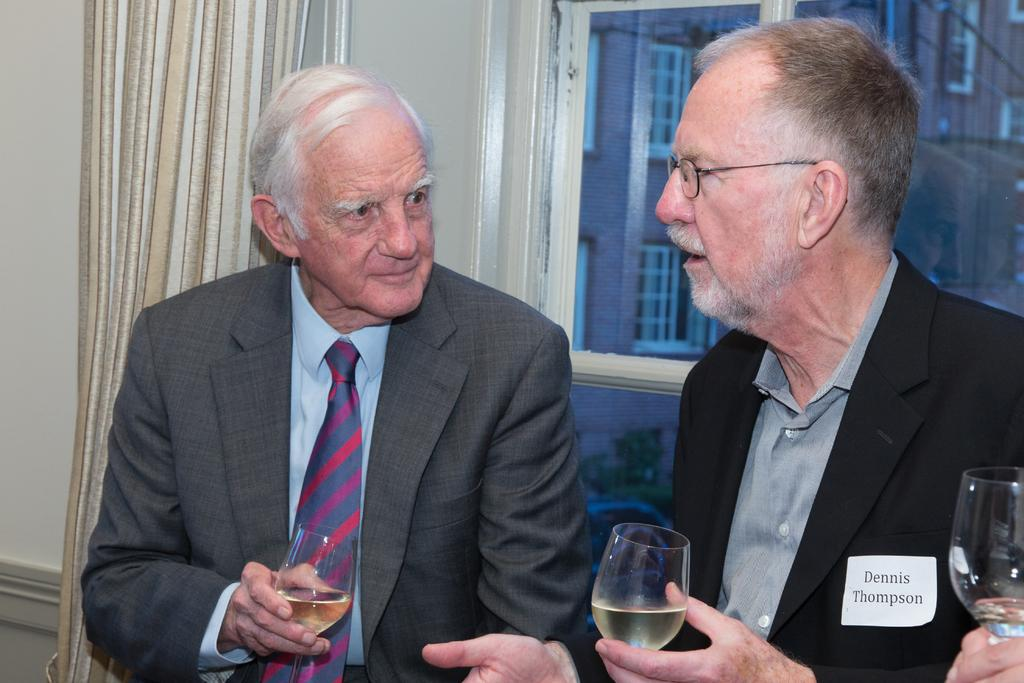How many people are in the image? There are two persons in the image. What are the two persons holding in their hands? The two persons are holding glasses with liquid. What are the two persons wearing? The two persons are wearing suits. What can be seen through the window in the image? A building with windows is visible through the window. What is associated with the window in the image? There is a curtain associated with the window. What type of record is being played in the image? There is no record or music player present in the image. What payment method is being used by the two persons in the image? There is no indication of any payment method being used in the image. 